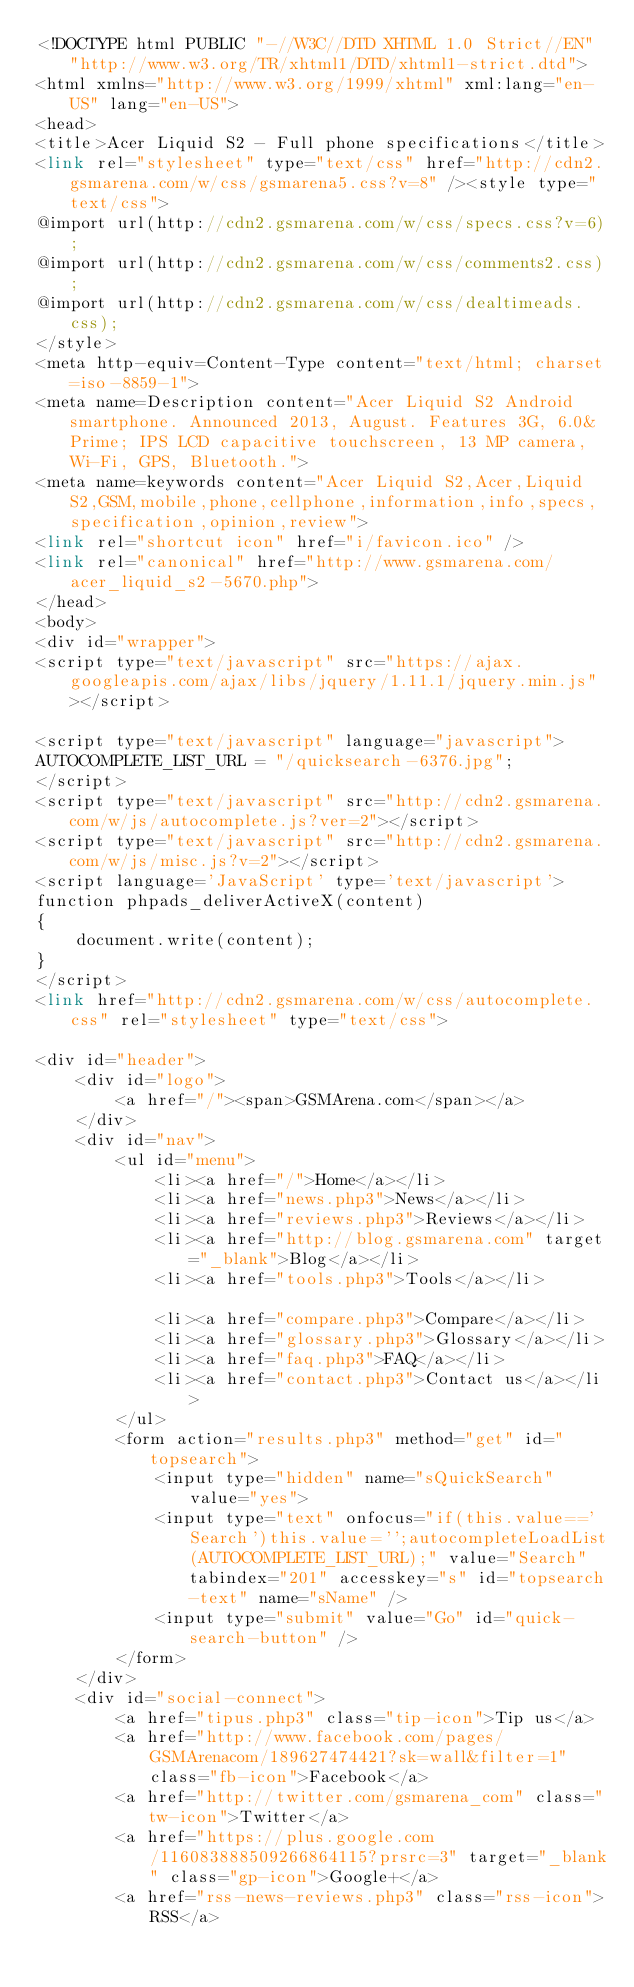Convert code to text. <code><loc_0><loc_0><loc_500><loc_500><_PHP_><!DOCTYPE html PUBLIC "-//W3C//DTD XHTML 1.0 Strict//EN" "http://www.w3.org/TR/xhtml1/DTD/xhtml1-strict.dtd">
<html xmlns="http://www.w3.org/1999/xhtml" xml:lang="en-US" lang="en-US">
<head>
<title>Acer Liquid S2 - Full phone specifications</title>
<link rel="stylesheet" type="text/css" href="http://cdn2.gsmarena.com/w/css/gsmarena5.css?v=8" /><style type="text/css">
@import url(http://cdn2.gsmarena.com/w/css/specs.css?v=6);
@import url(http://cdn2.gsmarena.com/w/css/comments2.css);
@import url(http://cdn2.gsmarena.com/w/css/dealtimeads.css);
</style>
<meta http-equiv=Content-Type content="text/html; charset=iso-8859-1">
<meta name=Description content="Acer Liquid S2 Android smartphone. Announced 2013, August. Features 3G, 6.0&Prime; IPS LCD capacitive touchscreen, 13 MP camera, Wi-Fi, GPS, Bluetooth.">
<meta name=keywords content="Acer Liquid S2,Acer,Liquid S2,GSM,mobile,phone,cellphone,information,info,specs,specification,opinion,review">
<link rel="shortcut icon" href="i/favicon.ico" />
<link rel="canonical" href="http://www.gsmarena.com/acer_liquid_s2-5670.php">
</head>
<body>
<div id="wrapper">
<script type="text/javascript" src="https://ajax.googleapis.com/ajax/libs/jquery/1.11.1/jquery.min.js"></script>

<script type="text/javascript" language="javascript">
AUTOCOMPLETE_LIST_URL = "/quicksearch-6376.jpg";
</script>
<script type="text/javascript" src="http://cdn2.gsmarena.com/w/js/autocomplete.js?ver=2"></script>
<script type="text/javascript" src="http://cdn2.gsmarena.com/w/js/misc.js?v=2"></script>
<script language='JavaScript' type='text/javascript'>
function phpads_deliverActiveX(content)
{
	document.write(content);	
}
</script>
<link href="http://cdn2.gsmarena.com/w/css/autocomplete.css" rel="stylesheet" type="text/css">

<div id="header">
	<div id="logo">
    	<a href="/"><span>GSMArena.com</span></a>
    </div>
	<div id="nav">
    	<ul id="menu">
        	<li><a href="/">Home</a></li>
        	<li><a href="news.php3">News</a></li>
        	<li><a href="reviews.php3">Reviews</a></li>
        	<li><a href="http://blog.gsmarena.com" target="_blank">Blog</a></li>
			<li><a href="tools.php3">Tools</a></li>			
        	<li><a href="compare.php3">Compare</a></li>
        	<li><a href="glossary.php3">Glossary</a></li>
        	<li><a href="faq.php3">FAQ</a></li>
        	<li><a href="contact.php3">Contact us</a></li>
        </ul>
        <form action="results.php3" method="get" id="topsearch">
            <input type="hidden" name="sQuickSearch" value="yes">
            <input type="text" onfocus="if(this.value=='Search')this.value='';autocompleteLoadList(AUTOCOMPLETE_LIST_URL);" value="Search" tabindex="201" accesskey="s" id="topsearch-text" name="sName" />
            <input type="submit" value="Go" id="quick-search-button" />
        </form>
    </div>
    <div id="social-connect">
    	<a href="tipus.php3" class="tip-icon">Tip us</a>
    	<a href="http://www.facebook.com/pages/GSMArenacom/189627474421?sk=wall&filter=1" class="fb-icon">Facebook</a>
        <a href="http://twitter.com/gsmarena_com" class="tw-icon">Twitter</a>
		<a href="https://plus.google.com/116083888509266864115?prsrc=3" target="_blank" class="gp-icon">Google+</a>
        <a href="rss-news-reviews.php3" class="rss-icon">RSS</a></code> 